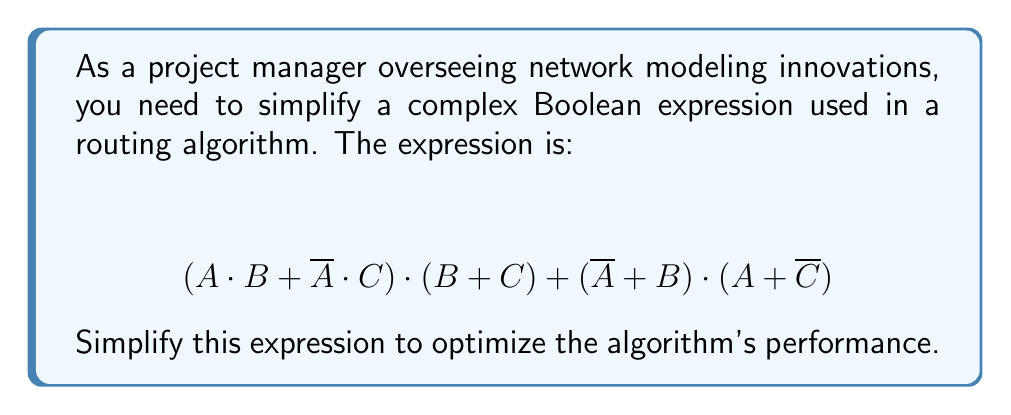Provide a solution to this math problem. Let's simplify this expression step by step:

1) First, let's distribute the first term:
   $$(A \cdot B + \overline{A} \cdot C) \cdot (B + C) = A \cdot B \cdot B + A \cdot B \cdot C + \overline{A} \cdot C \cdot B + \overline{A} \cdot C \cdot C$$

2) Simplify using the idempotent law $(X \cdot X = X)$:
   $$A \cdot B + A \cdot B \cdot C + \overline{A} \cdot C \cdot B + \overline{A} \cdot C$$

3) Now, let's distribute the second term:
   $$(\overline{A} + B) \cdot (A + \overline{C}) = \overline{A} \cdot A + \overline{A} \cdot \overline{C} + B \cdot A + B \cdot \overline{C}$$

4) Simplify using the complement law $(\overline{X} \cdot X = 0)$:
   $$\overline{A} \cdot \overline{C} + B \cdot A + B \cdot \overline{C}$$

5) Now we have:
   $$(A \cdot B + A \cdot B \cdot C + \overline{A} \cdot C \cdot B + \overline{A} \cdot C) + (\overline{A} \cdot \overline{C} + B \cdot A + B \cdot \overline{C})$$

6) Rearrange terms:
   $$A \cdot B + A \cdot B \cdot C + \overline{A} \cdot C \cdot B + \overline{A} \cdot C + \overline{A} \cdot \overline{C} + B \cdot A + B \cdot \overline{C}$$

7) Combine like terms:
   $$A \cdot B + \overline{A} \cdot C + \overline{A} \cdot \overline{C} + B \cdot \overline{C}$$

8) Use the distributive law:
   $$A \cdot B + \overline{A} \cdot (C + \overline{C}) + B \cdot \overline{C}$$

9) Simplify using the complement law $(X + \overline{X} = 1)$:
   $$A \cdot B + \overline{A} + B \cdot \overline{C}$$

10) Use the absorption law $(X + X \cdot Y = X)$:
    $$A \cdot B + \overline{A} + B \cdot \overline{C} = B + \overline{A}$$

This is the simplified expression.
Answer: $$B + \overline{A}$$ 